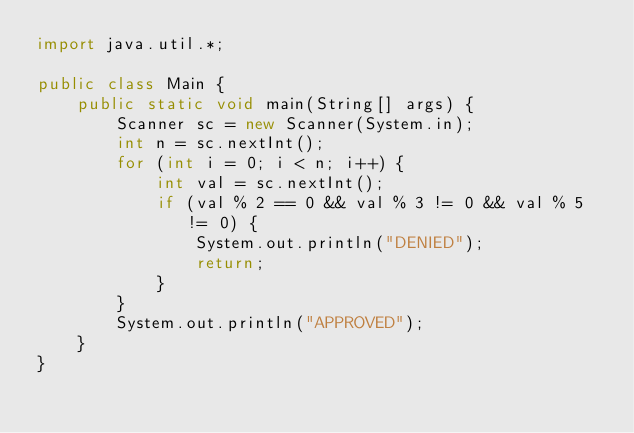Convert code to text. <code><loc_0><loc_0><loc_500><loc_500><_Java_>import java.util.*;

public class Main {
    public static void main(String[] args) {
        Scanner sc = new Scanner(System.in);
        int n = sc.nextInt();
        for (int i = 0; i < n; i++) {
            int val = sc.nextInt();
            if (val % 2 == 0 && val % 3 != 0 && val % 5 != 0) {
                System.out.println("DENIED");
                return;
            }
        }
        System.out.println("APPROVED");
    }
}
</code> 